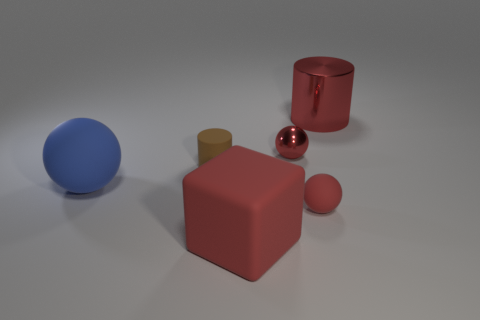Add 2 large red objects. How many objects exist? 8 Subtract all cylinders. How many objects are left? 4 Subtract all large yellow cylinders. Subtract all matte cubes. How many objects are left? 5 Add 2 metal objects. How many metal objects are left? 4 Add 1 big brown metallic objects. How many big brown metallic objects exist? 1 Subtract 0 blue blocks. How many objects are left? 6 